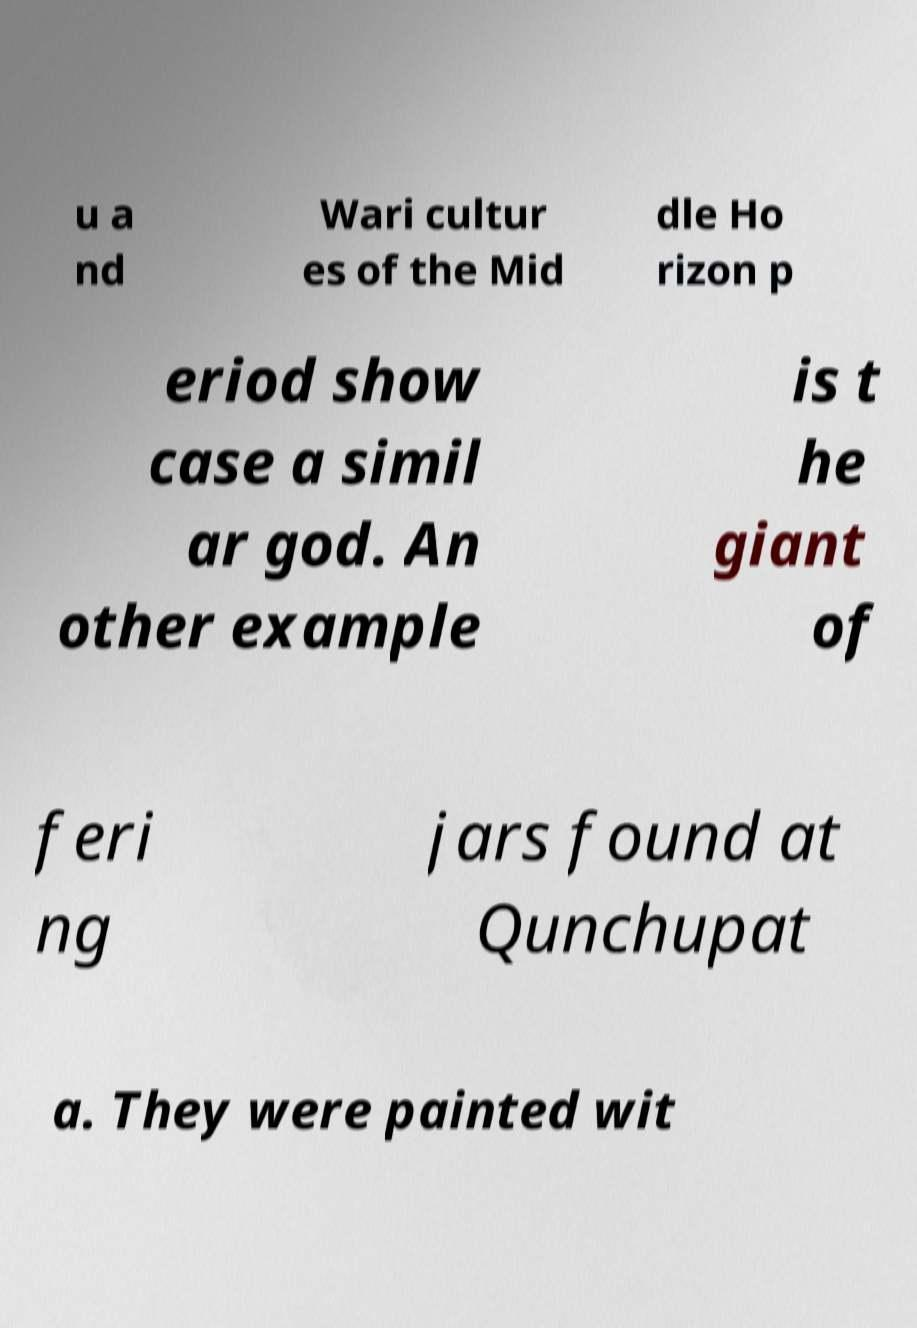Could you extract and type out the text from this image? u a nd Wari cultur es of the Mid dle Ho rizon p eriod show case a simil ar god. An other example is t he giant of feri ng jars found at Qunchupat a. They were painted wit 